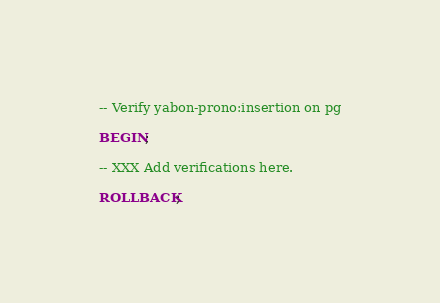Convert code to text. <code><loc_0><loc_0><loc_500><loc_500><_SQL_>-- Verify yabon-prono:insertion on pg

BEGIN;

-- XXX Add verifications here.

ROLLBACK;
</code> 